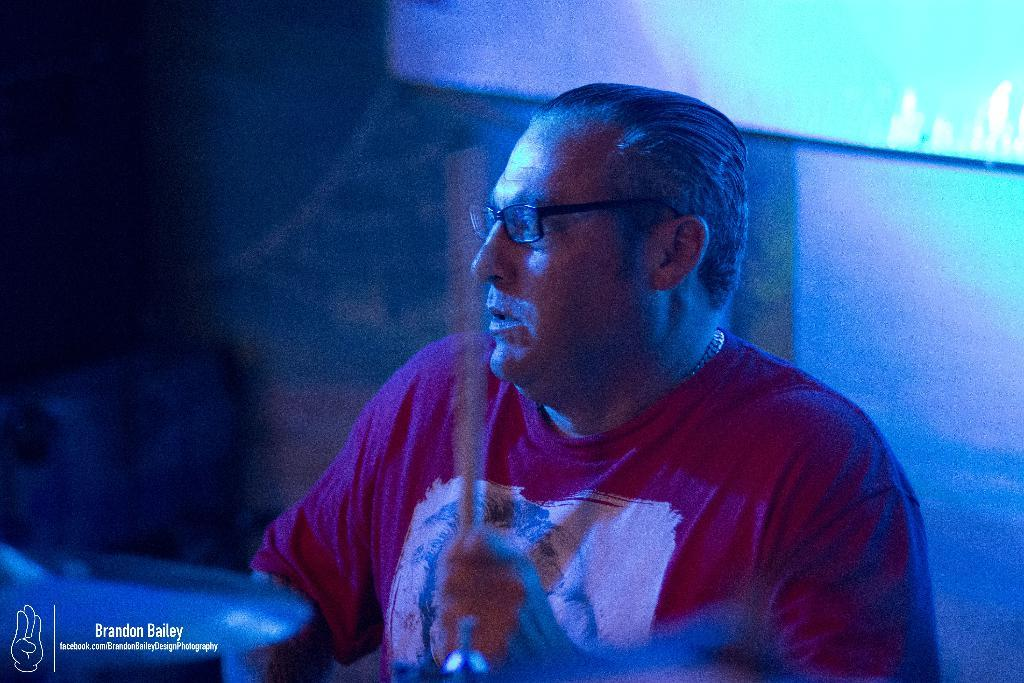What is the main subject of the picture? The main subject of the picture is a man. Can you describe the man's appearance? The man is wearing spectacles. What is the man holding in the picture? The man is holding a stick. What other object can be seen in the image? There is a cymbal in the picture. How would you describe the background of the image? The background of the image is blurred. What type of fork is the man using to eat the pear in the image? There is no fork or pear present in the image. 